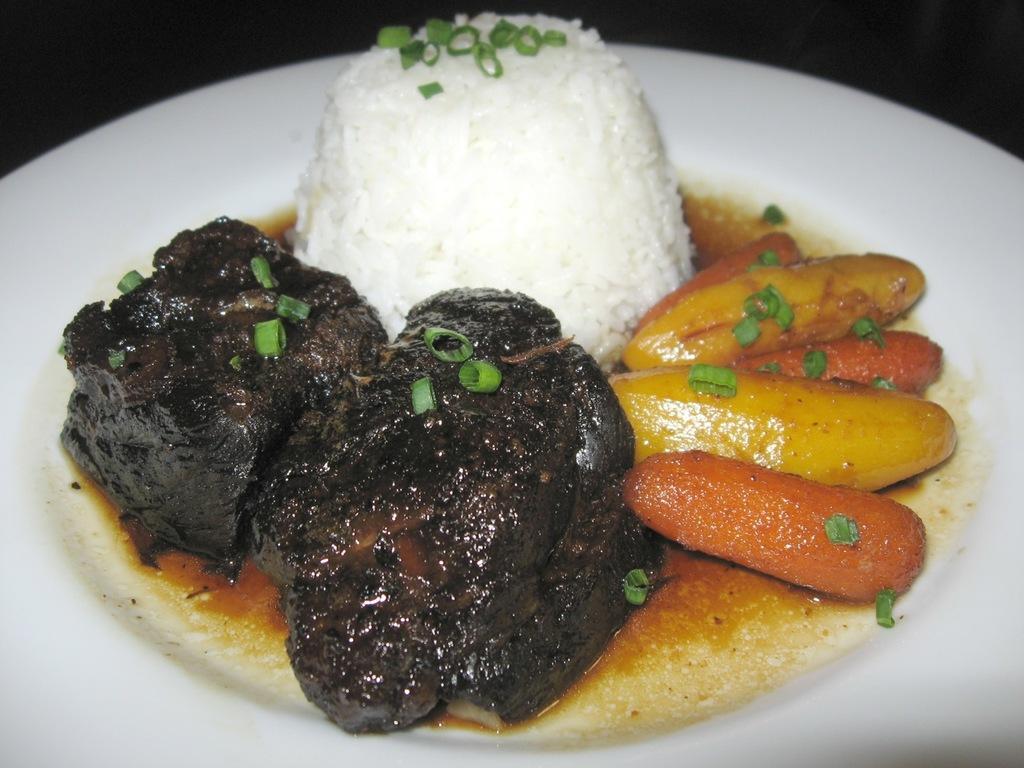In one or two sentences, can you explain what this image depicts? In this picture there is a plate in the center of the image, which contains dessert items in it. 